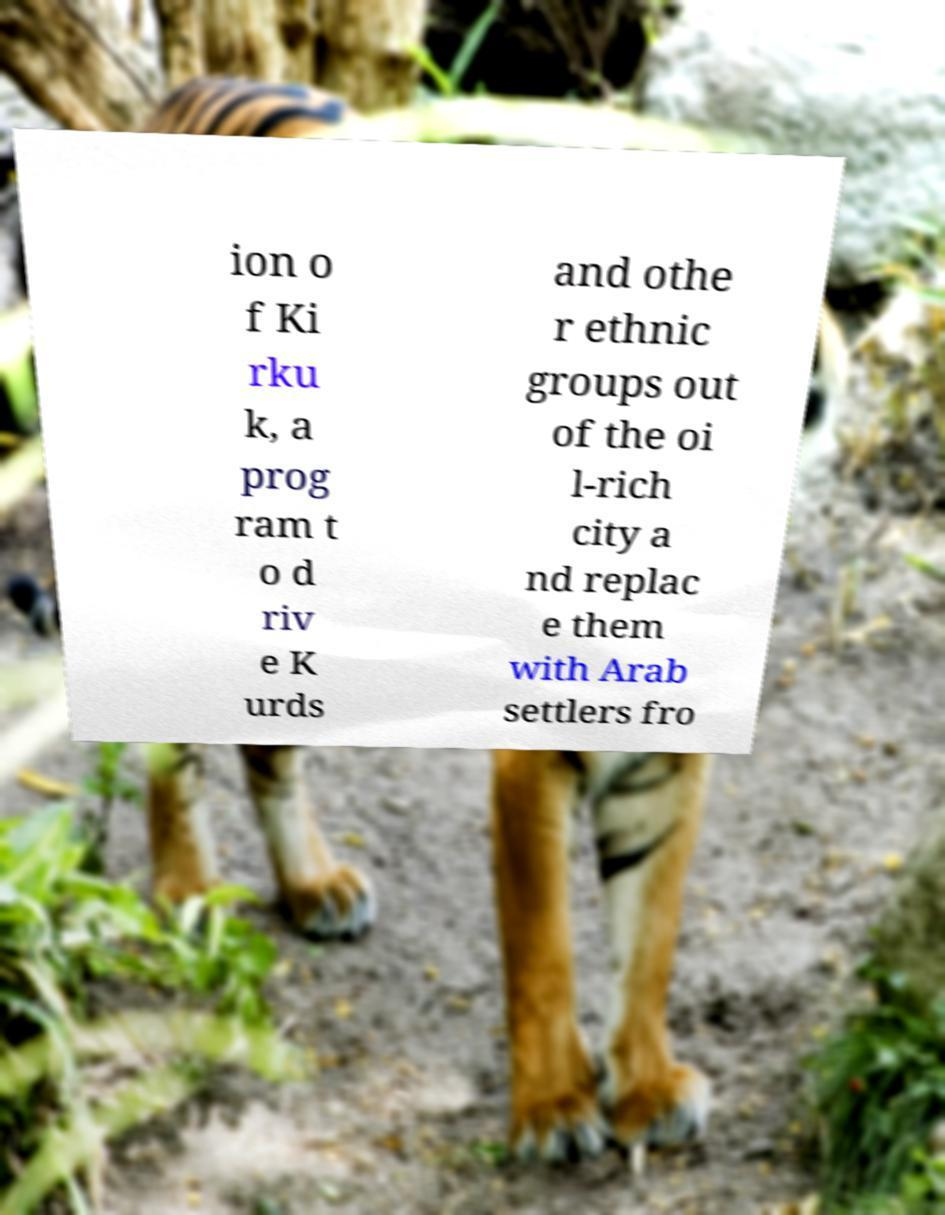Can you read and provide the text displayed in the image?This photo seems to have some interesting text. Can you extract and type it out for me? ion o f Ki rku k, a prog ram t o d riv e K urds and othe r ethnic groups out of the oi l-rich city a nd replac e them with Arab settlers fro 